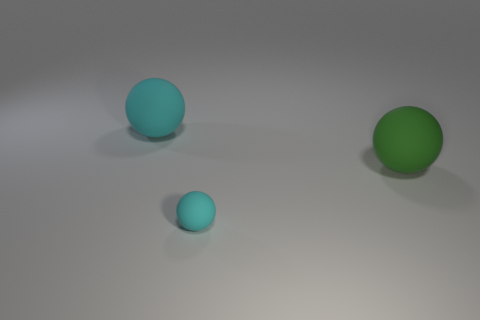Add 1 big cyan objects. How many objects exist? 4 Add 3 big green matte balls. How many big green matte balls are left? 4 Add 3 cyan things. How many cyan things exist? 5 Subtract 0 green cubes. How many objects are left? 3 Subtract all large purple matte cylinders. Subtract all green objects. How many objects are left? 2 